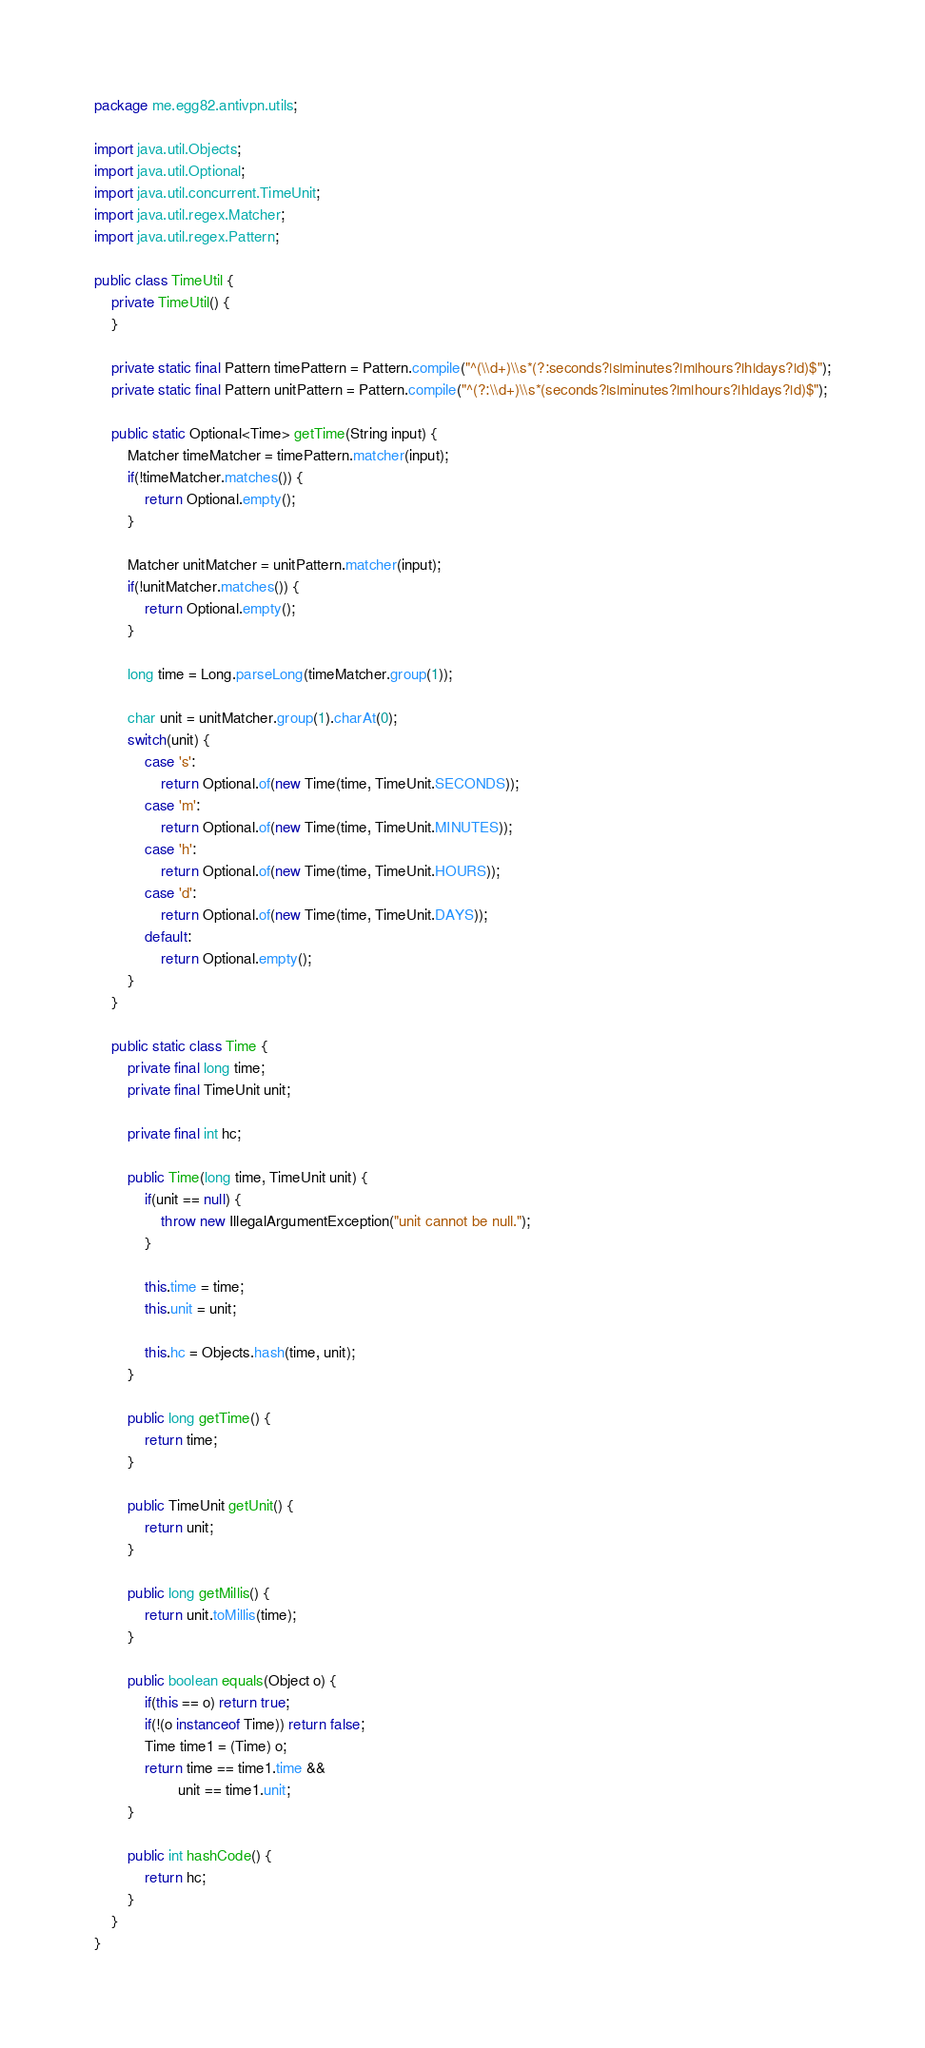Convert code to text. <code><loc_0><loc_0><loc_500><loc_500><_Java_>package me.egg82.antivpn.utils;

import java.util.Objects;
import java.util.Optional;
import java.util.concurrent.TimeUnit;
import java.util.regex.Matcher;
import java.util.regex.Pattern;

public class TimeUtil {
    private TimeUtil() {
    }

    private static final Pattern timePattern = Pattern.compile("^(\\d+)\\s*(?:seconds?|s|minutes?|m|hours?|h|days?|d)$");
    private static final Pattern unitPattern = Pattern.compile("^(?:\\d+)\\s*(seconds?|s|minutes?|m|hours?|h|days?|d)$");

    public static Optional<Time> getTime(String input) {
        Matcher timeMatcher = timePattern.matcher(input);
        if(!timeMatcher.matches()) {
            return Optional.empty();
        }

        Matcher unitMatcher = unitPattern.matcher(input);
        if(!unitMatcher.matches()) {
            return Optional.empty();
        }

        long time = Long.parseLong(timeMatcher.group(1));

        char unit = unitMatcher.group(1).charAt(0);
        switch(unit) {
            case 's':
                return Optional.of(new Time(time, TimeUnit.SECONDS));
            case 'm':
                return Optional.of(new Time(time, TimeUnit.MINUTES));
            case 'h':
                return Optional.of(new Time(time, TimeUnit.HOURS));
            case 'd':
                return Optional.of(new Time(time, TimeUnit.DAYS));
            default:
                return Optional.empty();
        }
    }

    public static class Time {
        private final long time;
        private final TimeUnit unit;

        private final int hc;

        public Time(long time, TimeUnit unit) {
            if(unit == null) {
                throw new IllegalArgumentException("unit cannot be null.");
            }

            this.time = time;
            this.unit = unit;

            this.hc = Objects.hash(time, unit);
        }

        public long getTime() {
            return time;
        }

        public TimeUnit getUnit() {
            return unit;
        }

        public long getMillis() {
            return unit.toMillis(time);
        }

        public boolean equals(Object o) {
            if(this == o) return true;
            if(!(o instanceof Time)) return false;
            Time time1 = (Time) o;
            return time == time1.time &&
                    unit == time1.unit;
        }

        public int hashCode() {
            return hc;
        }
    }
}
</code> 